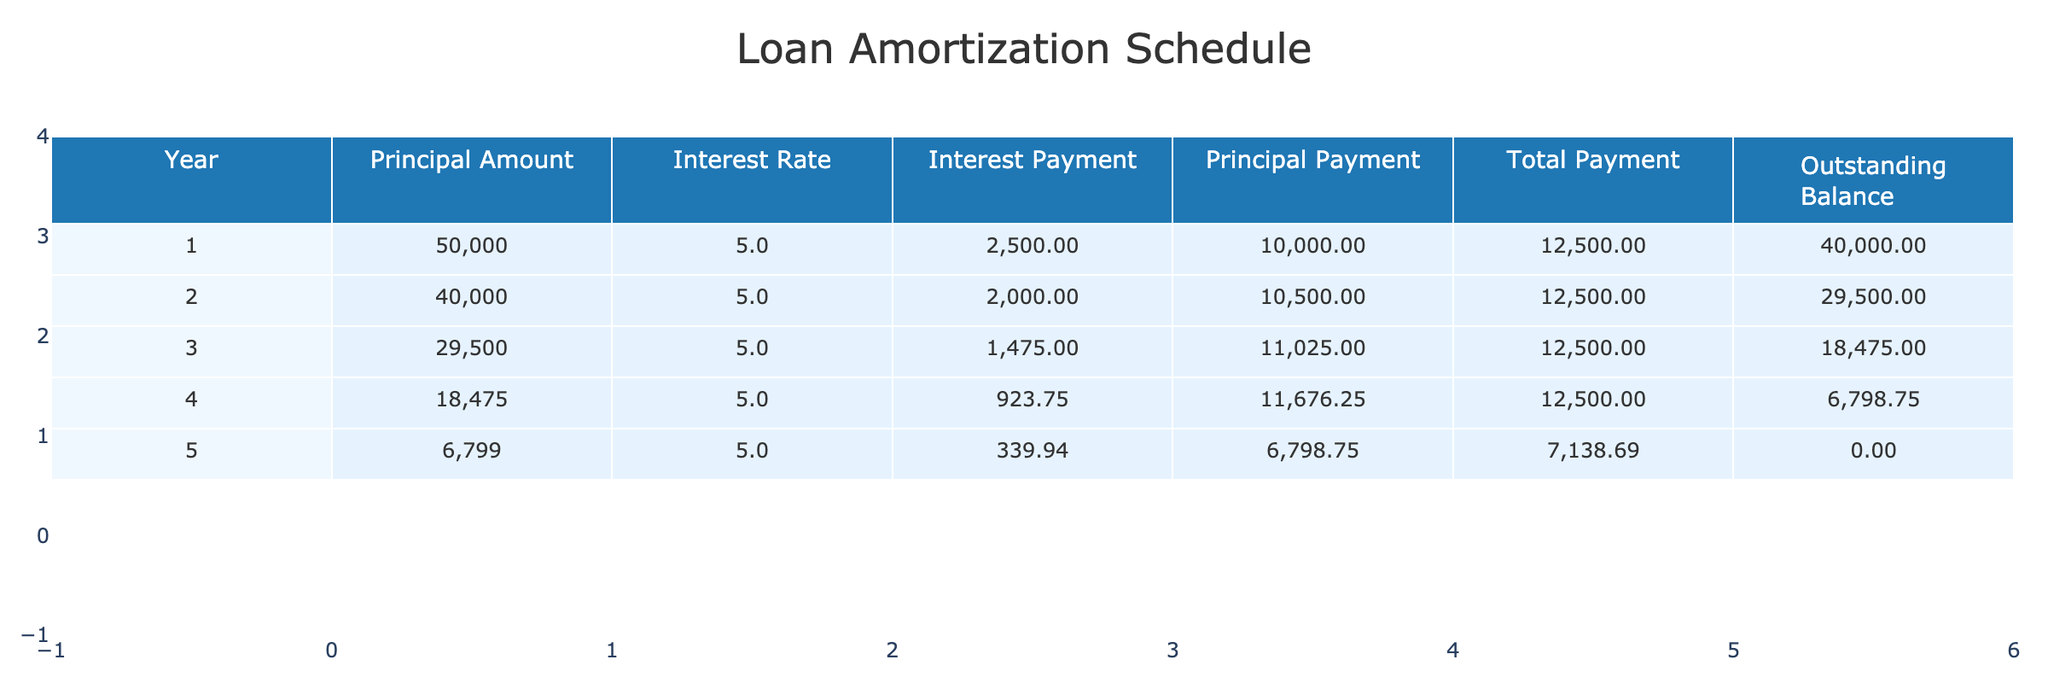What is the total payment made in the third year? Referring to the table, the total payment in the third year is listed as $12,500.
Answer: 12500 How much interest was paid in the second year? According to the table, the interest payment for the second year is documented as $2,000.
Answer: 2000 What is the total interest paid over the five years? To find the total interest paid, we sum the interest payments from all years: 2500 + 2000 + 1475 + 923.75 + 339.94 = 8,238.69.
Answer: 8238.69 Is the principal payment in the fourth year greater than in the second year? The principal payment in the fourth year is $11,676.25, while in the second year, it is $10,500. Since 11,676.25 is greater than 10,500, the answer is yes.
Answer: Yes What is the outstanding balance after the first year? The table indicates that after the first year, the outstanding balance is $40,000.
Answer: 40000 Calculate the average principal payment over the five years. The principal payments are: 10,000 + 10,500 + 11,025 + 11,676.25 + 6,798.75 = 49,000. Dividing by 5 gives an average of 49,000/5 = 9,800.
Answer: 9800 In how many years was the total payment consistent? The total payment is consistently $12,500 in years 1, 2, 3, and 4, but different in year 5. This indicates consistency in 4 years.
Answer: 4 Which year saw the highest principal payment, and how much was it? Analyzing the table data, the highest principal payment occurs in the fourth year, amounting to $11,676.25.
Answer: 11676.25 What percentage of the total payments in year 5 was principal payment? In year 5, the total payment is $7,138.69, with a principal payment of $6,798.75. The percentage is calculated as (6798.75 / 7138.69) * 100 = 95%.
Answer: 95% 